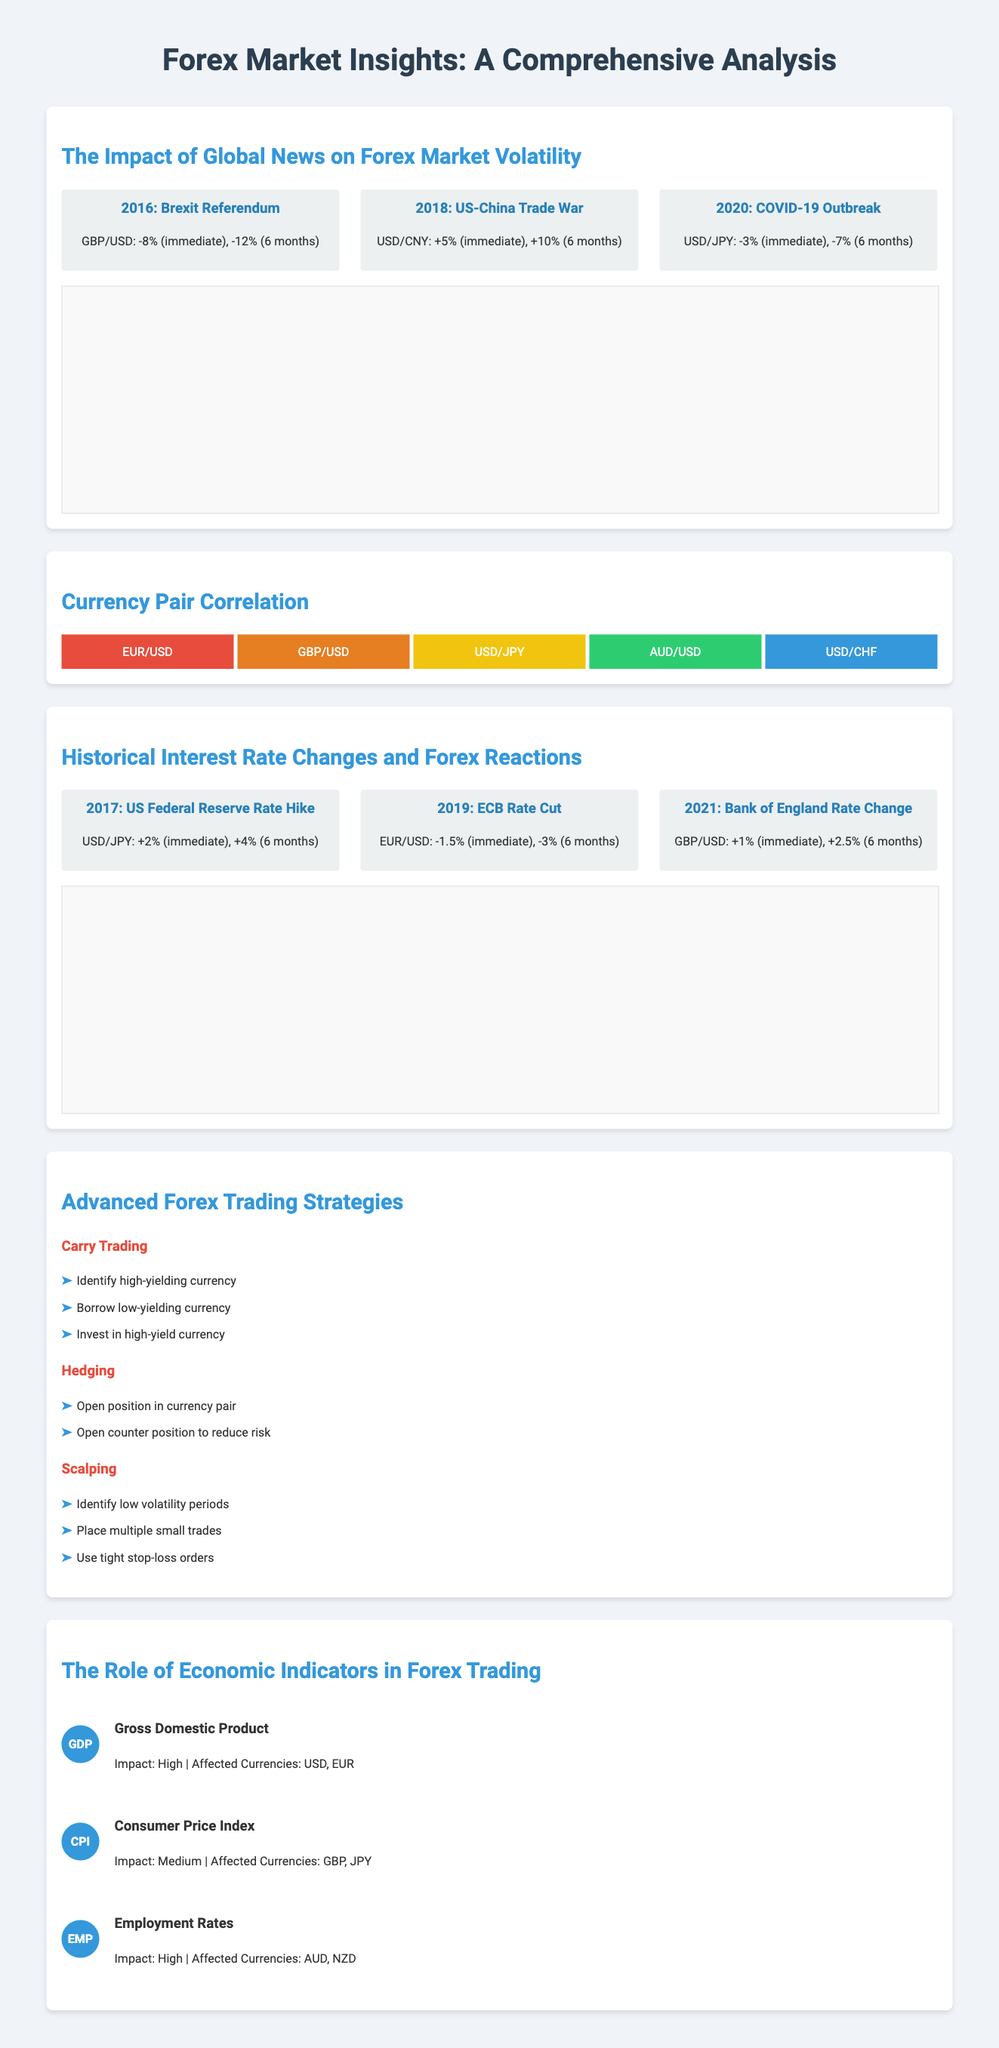What was the immediate effect of the Brexit Referendum on GBP/USD? The immediate effect of the Brexit Referendum on GBP/USD was a decline of 8%.
Answer: -8% What was the impact on USD/CNY during the US-China Trade War? The impact on USD/CNY during the US-China Trade War was an increase of 5% immediately.
Answer: +5% Which economic indicator has a high impact and affects USD and EUR? The economic indicator with a high impact that affects USD and EUR is Gross Domestic Product.
Answer: Gross Domestic Product What strategy involves borrowing a low-yielding currency? The strategy that involves borrowing a low-yielding currency is Carry Trading.
Answer: Carry Trading What was the percentage change of EUR/USD after the ECB's Rate Cut in 2019 over six months? The percentage change of EUR/USD after the ECB's Rate Cut in 2019 over six months was -3%.
Answer: -3% Which currency pair had a 2% increase after the US Federal Reserve Rate Hike in 2017? The currency pair that had a 2% increase after the US Federal Reserve Rate Hike in 2017 was USD/JPY.
Answer: USD/JPY What color represents GBP/USD in the currency pair correlation heatmap? The color representing GBP/USD in the currency pair correlation heatmap is orange.
Answer: Orange How many steps are there in the Scalping trading strategy? There are three steps in the Scalping trading strategy.
Answer: Three steps 